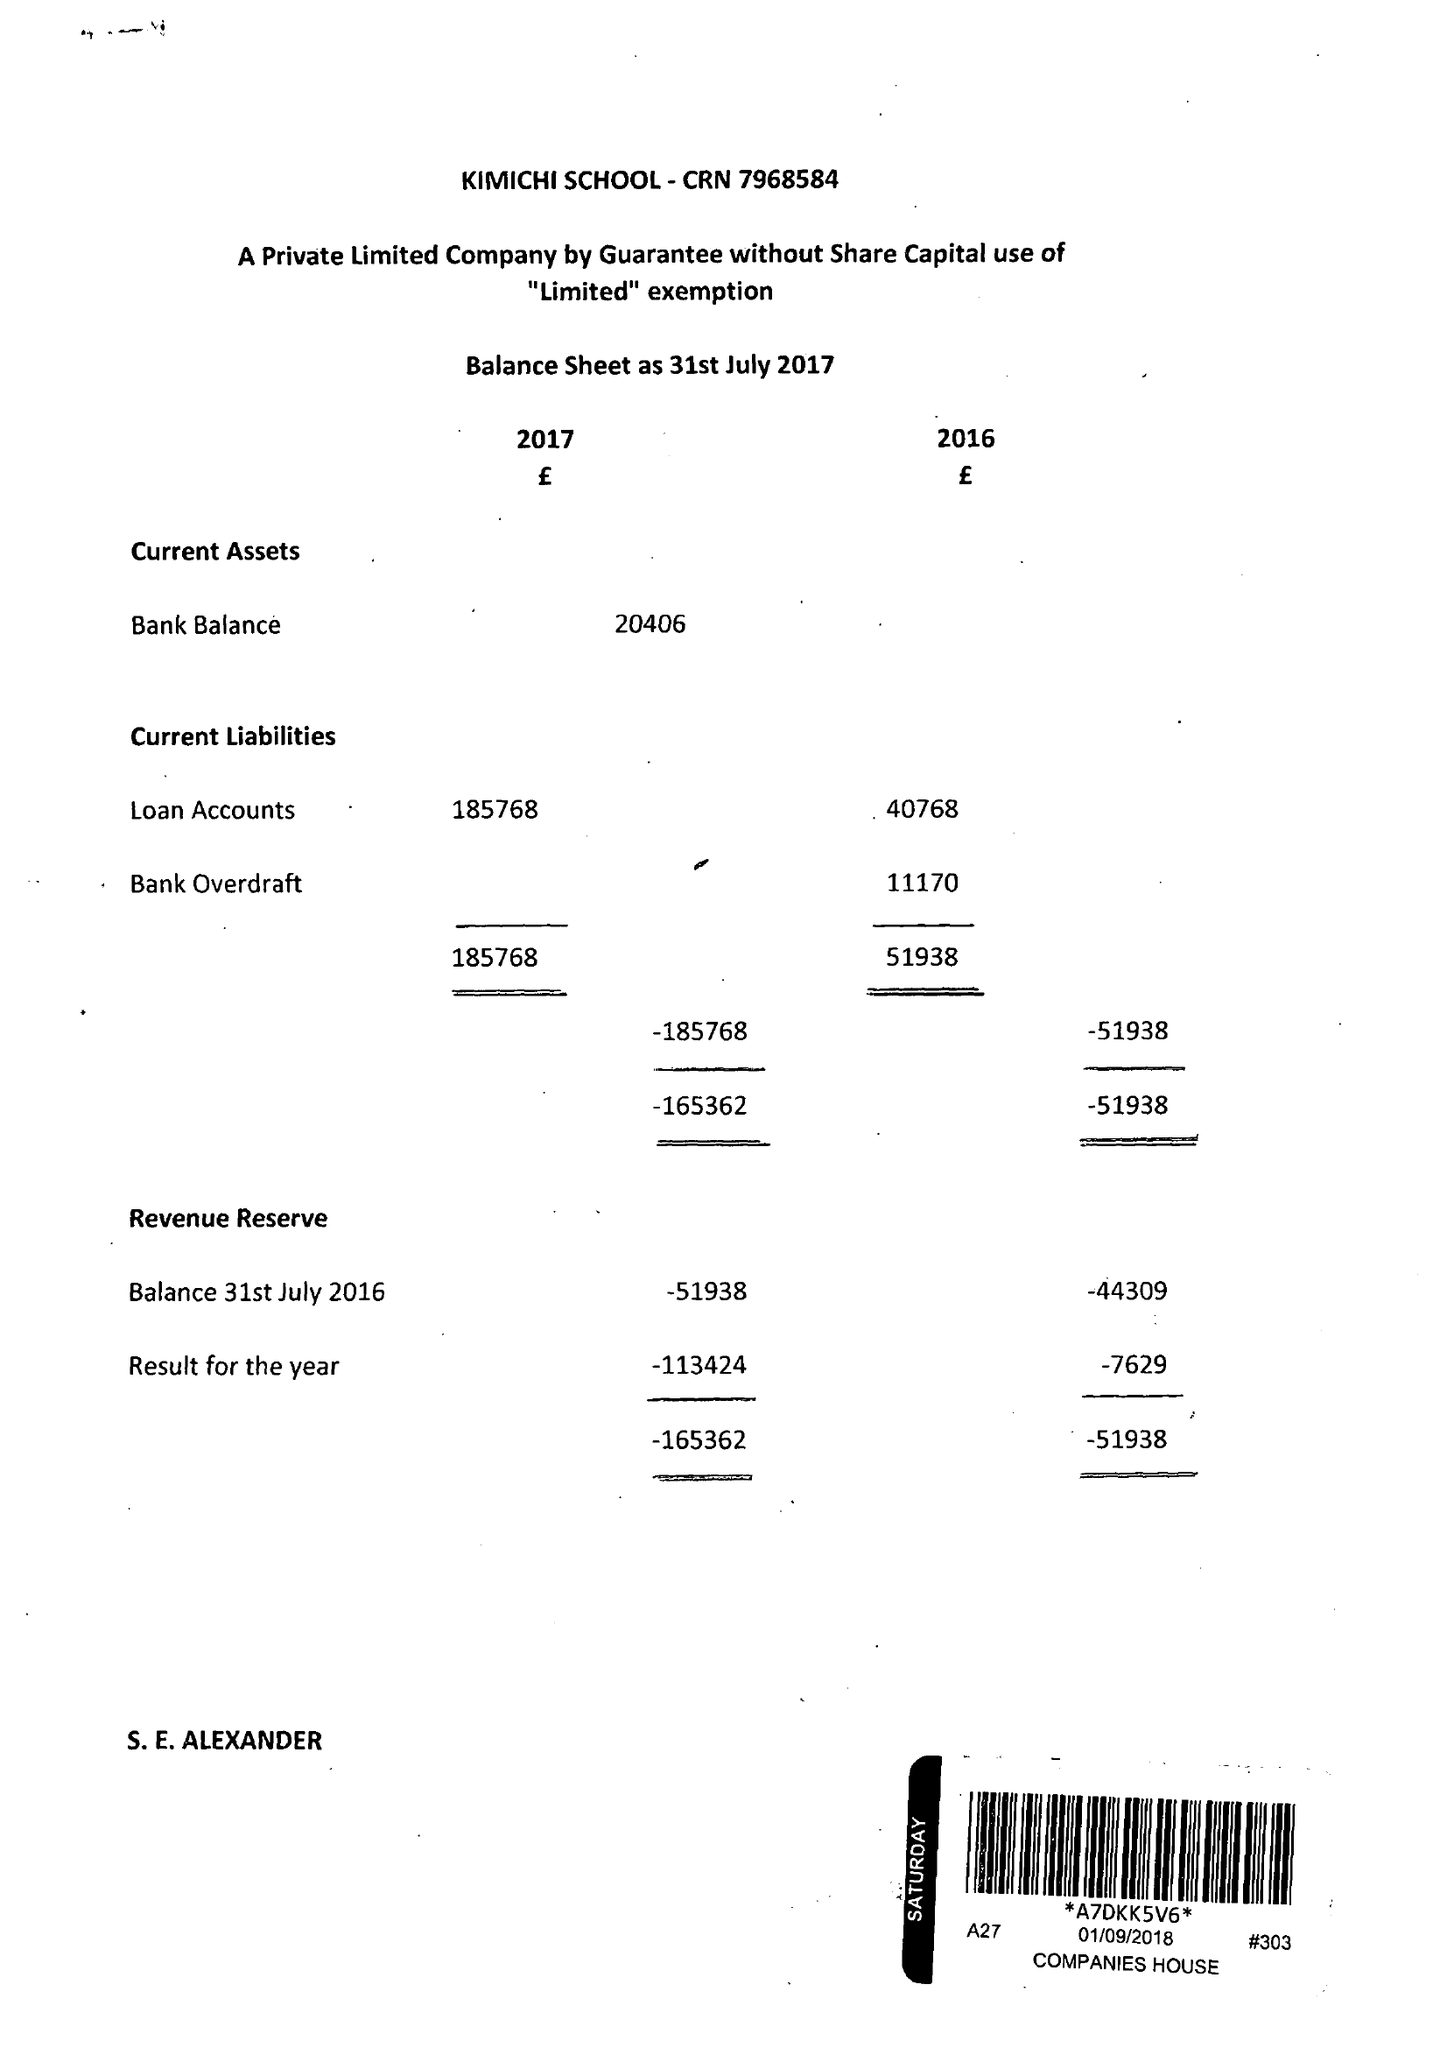What is the value for the address__post_town?
Answer the question using a single word or phrase. BIRMINGHAM 